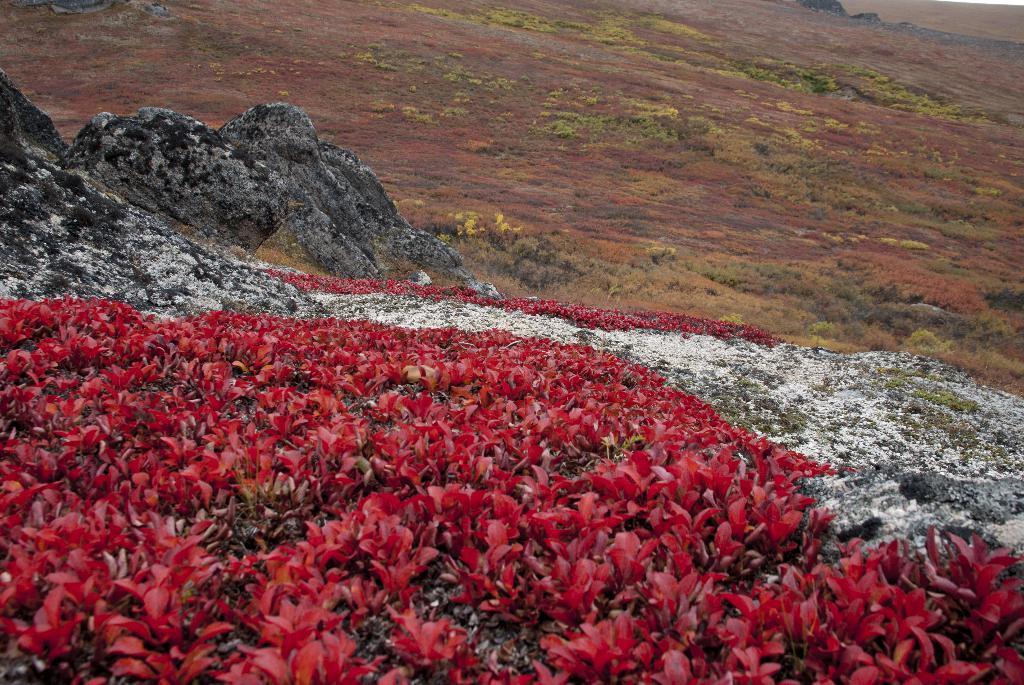How would you summarize this image in a sentence or two? In this image we can see few flowers, plants, grass and few rock stones. 